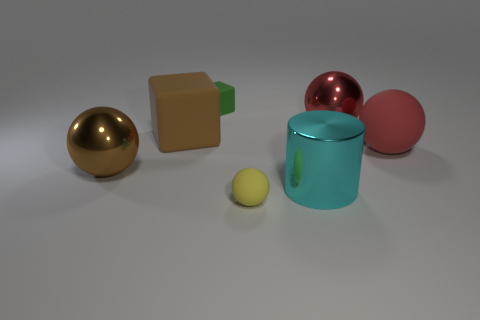What material is the large brown ball? The image does not contain a large brown ball. There is a large gold-colored ball that appears metallic due to its reflective surface. 